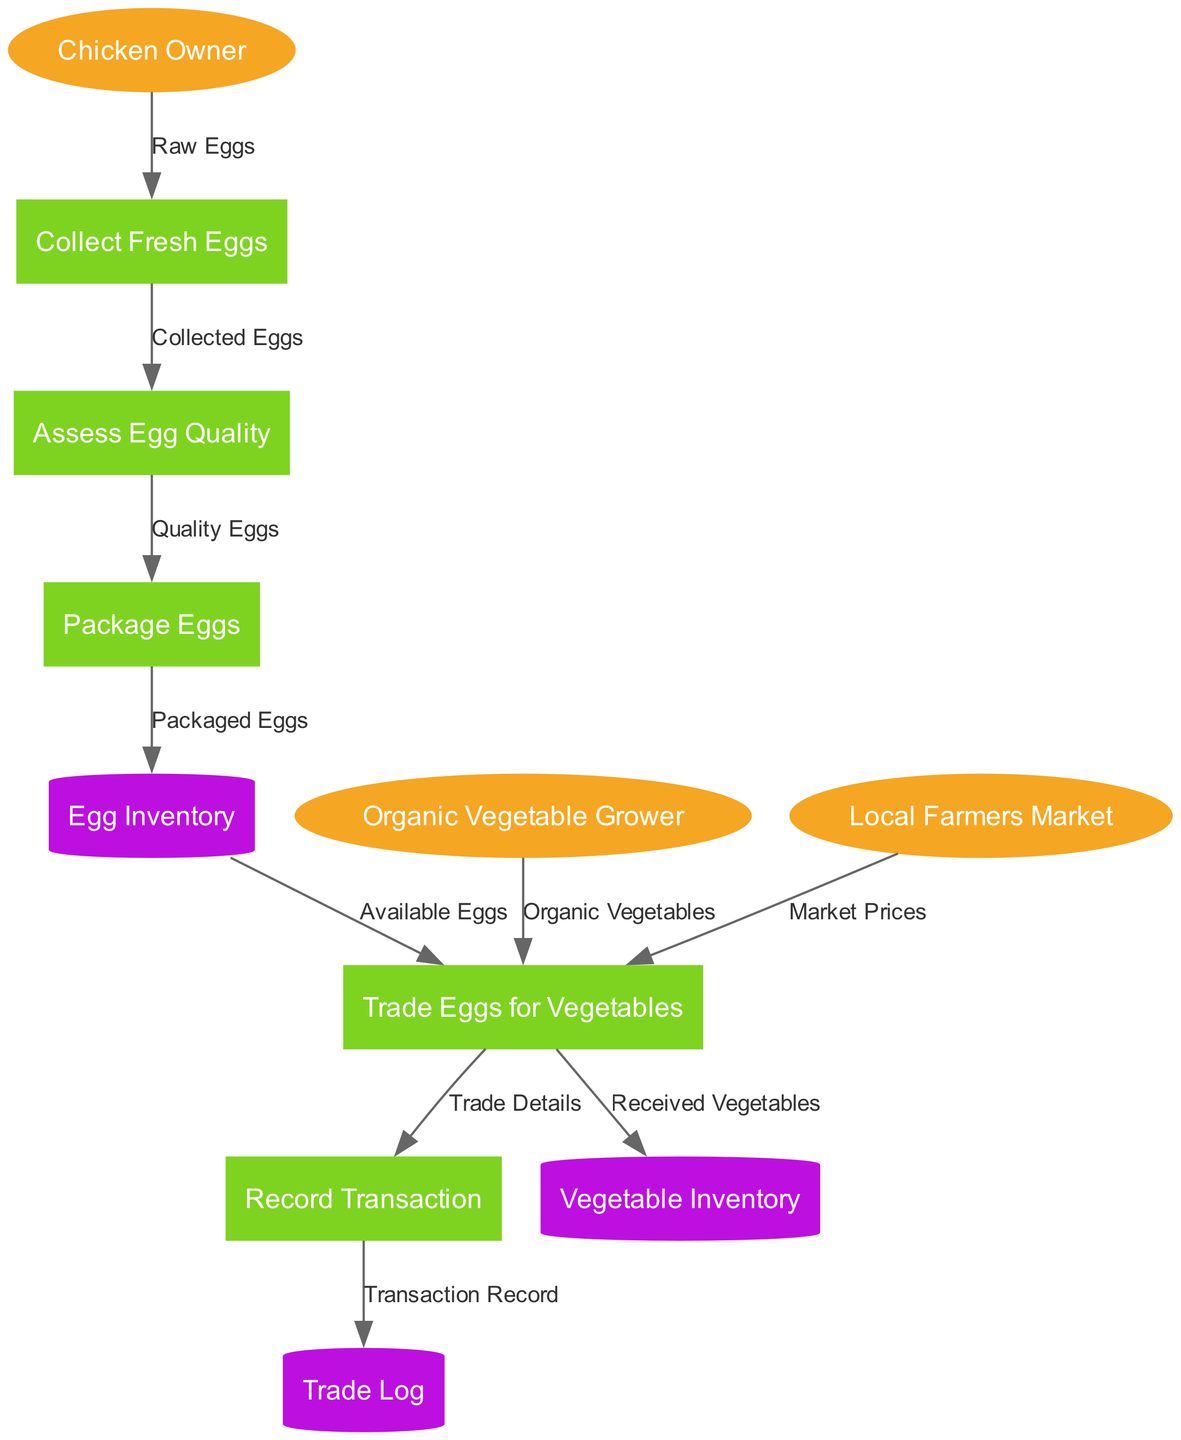What are the external entities in the diagram? The external entities listed in the diagram are Chicken Owner, Organic Vegetable Grower, and Local Farmers Market. These entities interact with the processes in the system.
Answer: Chicken Owner, Organic Vegetable Grower, Local Farmers Market How many processes are defined in the diagram? The diagram contains a total of five processes: Collect Fresh Eggs, Assess Egg Quality, Package Eggs, Trade Eggs for Vegetables, and Record Transaction.
Answer: 5 What is the first process that raw eggs flow into? The first data flow from the Chicken Owner shows that Raw Eggs are directed to the process called Collect Fresh Eggs, indicating that this process is the starting point of the egg collection.
Answer: Collect Fresh Eggs Which process is responsible for assessing the quality of eggs? The process named Assess Egg Quality is designated to evaluate the quality of the collected eggs before they are packaged for trade.
Answer: Assess Egg Quality What does the Egg Inventory store? The Egg Inventory data store holds the Packaged Eggs, which are ready for the trading process, indicating that it keeps track of what eggs are available for exchange.
Answer: Packaged Eggs How do organic vegetables enter the trade process? Organic vegetables are provided to the Trade Eggs for Vegetables process from the Organic Vegetable Grower, highlighting the direct input of the vegetables in this trade system.
Answer: Organic Vegetable Grower What happens to transaction records after being created? After the Record Transaction process generates a Transaction Record, this record is stored in the Trade Log, which serves to track all trade transactions systematically.
Answer: Trade Log What is the final outcome of trading eggs? The outcome of trading eggs is that Received Vegetables are stored in the Vegetable Inventory, indicating that the trade successfully results in acquiring vegetables.
Answer: Vegetable Inventory 